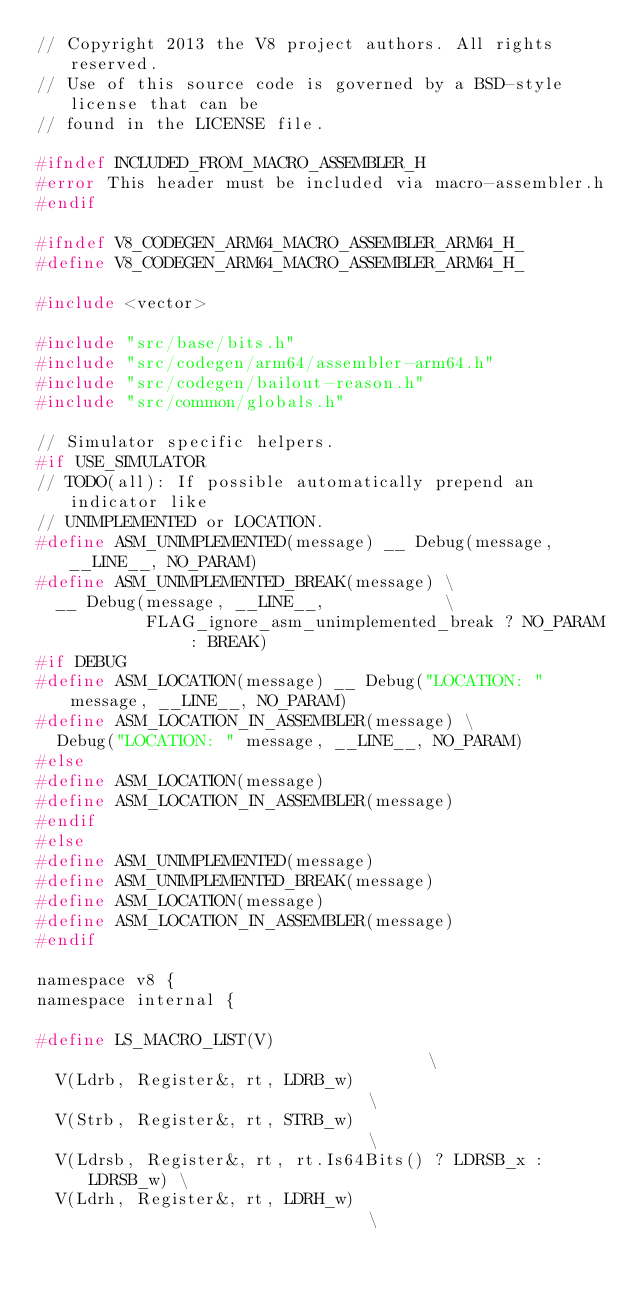<code> <loc_0><loc_0><loc_500><loc_500><_C_>// Copyright 2013 the V8 project authors. All rights reserved.
// Use of this source code is governed by a BSD-style license that can be
// found in the LICENSE file.

#ifndef INCLUDED_FROM_MACRO_ASSEMBLER_H
#error This header must be included via macro-assembler.h
#endif

#ifndef V8_CODEGEN_ARM64_MACRO_ASSEMBLER_ARM64_H_
#define V8_CODEGEN_ARM64_MACRO_ASSEMBLER_ARM64_H_

#include <vector>

#include "src/base/bits.h"
#include "src/codegen/arm64/assembler-arm64.h"
#include "src/codegen/bailout-reason.h"
#include "src/common/globals.h"

// Simulator specific helpers.
#if USE_SIMULATOR
// TODO(all): If possible automatically prepend an indicator like
// UNIMPLEMENTED or LOCATION.
#define ASM_UNIMPLEMENTED(message) __ Debug(message, __LINE__, NO_PARAM)
#define ASM_UNIMPLEMENTED_BREAK(message) \
  __ Debug(message, __LINE__,            \
           FLAG_ignore_asm_unimplemented_break ? NO_PARAM : BREAK)
#if DEBUG
#define ASM_LOCATION(message) __ Debug("LOCATION: " message, __LINE__, NO_PARAM)
#define ASM_LOCATION_IN_ASSEMBLER(message) \
  Debug("LOCATION: " message, __LINE__, NO_PARAM)
#else
#define ASM_LOCATION(message)
#define ASM_LOCATION_IN_ASSEMBLER(message)
#endif
#else
#define ASM_UNIMPLEMENTED(message)
#define ASM_UNIMPLEMENTED_BREAK(message)
#define ASM_LOCATION(message)
#define ASM_LOCATION_IN_ASSEMBLER(message)
#endif

namespace v8 {
namespace internal {

#define LS_MACRO_LIST(V)                                     \
  V(Ldrb, Register&, rt, LDRB_w)                             \
  V(Strb, Register&, rt, STRB_w)                             \
  V(Ldrsb, Register&, rt, rt.Is64Bits() ? LDRSB_x : LDRSB_w) \
  V(Ldrh, Register&, rt, LDRH_w)                             \</code> 